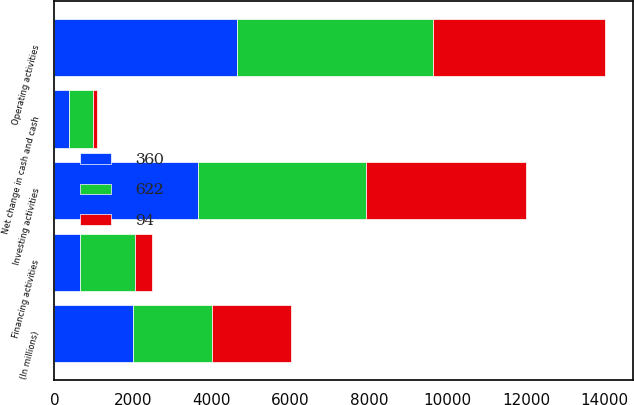Convert chart to OTSL. <chart><loc_0><loc_0><loc_500><loc_500><stacked_bar_chart><ecel><fcel>(In millions)<fcel>Operating activities<fcel>Investing activities<fcel>Financing activities<fcel>Net change in cash and cash<nl><fcel>622<fcel>2008<fcel>4965<fcel>4283<fcel>1383<fcel>622<nl><fcel>360<fcel>2007<fcel>4656<fcel>3654<fcel>655<fcel>360<nl><fcel>94<fcel>2006<fcel>4397<fcel>4057<fcel>434<fcel>94<nl></chart> 